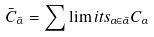<formula> <loc_0><loc_0><loc_500><loc_500>\bar { C } _ { \bar { \alpha } } = \sum \lim i t s _ { \alpha \in \bar { \alpha } } C _ { \alpha }</formula> 